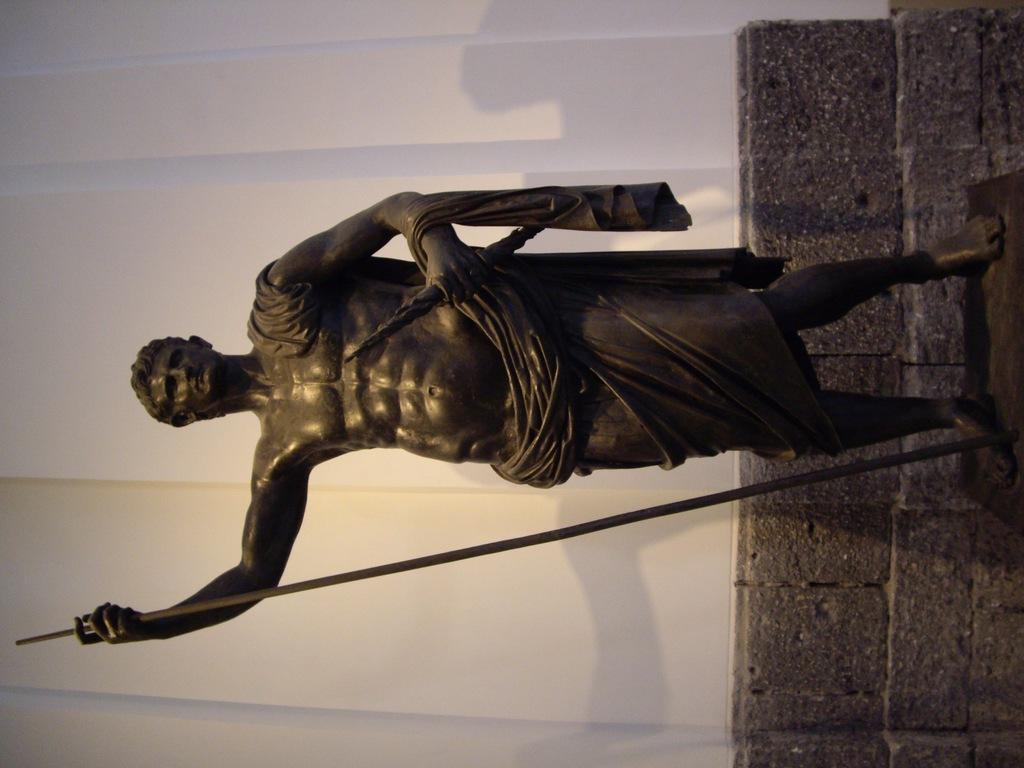What is the main subject in the center of the image? There is a statue of a person in the center of the image. What can be seen in the background of the image? There is a wall in the background of the image. What is the rate of the jam being spread on the wall in the image? There is no jam or any indication of spreading in the image; it features a statue of a person and a wall in the background. 